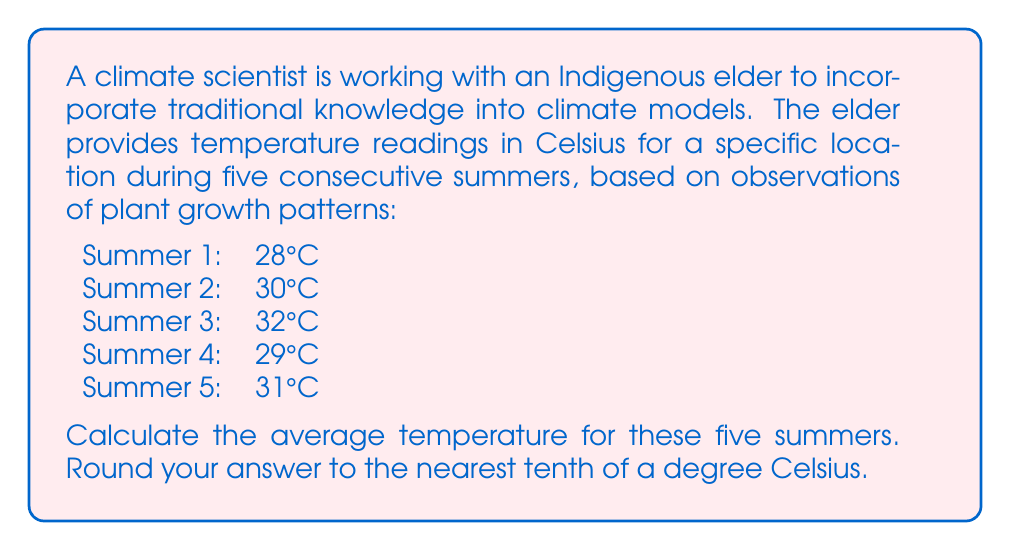What is the answer to this math problem? To find the average temperature, we need to follow these steps:

1. Sum up all the temperature readings:
   $28°C + 30°C + 32°C + 29°C + 31°C = 150°C$

2. Count the total number of readings:
   There are 5 summer readings.

3. Divide the sum by the number of readings:
   $$\text{Average} = \frac{\text{Sum of readings}}{\text{Number of readings}} = \frac{150°C}{5} = 30°C$$

4. Round to the nearest tenth of a degree:
   30°C is already rounded to the nearest tenth, so no further rounding is necessary.

This average temperature can be used in climate models to represent the typical summer temperature for this location, incorporating the traditional knowledge provided by the Indigenous elder.
Answer: $30.0°C$ 